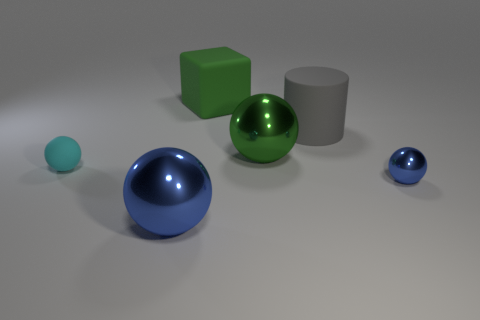Can you analyze the lighting in the scene? Certainly! The lighting in the image appears uniform and diffuse, with soft shadows emerging behind the objects. This could indicate an overcast sky or a softbox light source used in photography to eliminate harsh shadows and provide even illumination. 